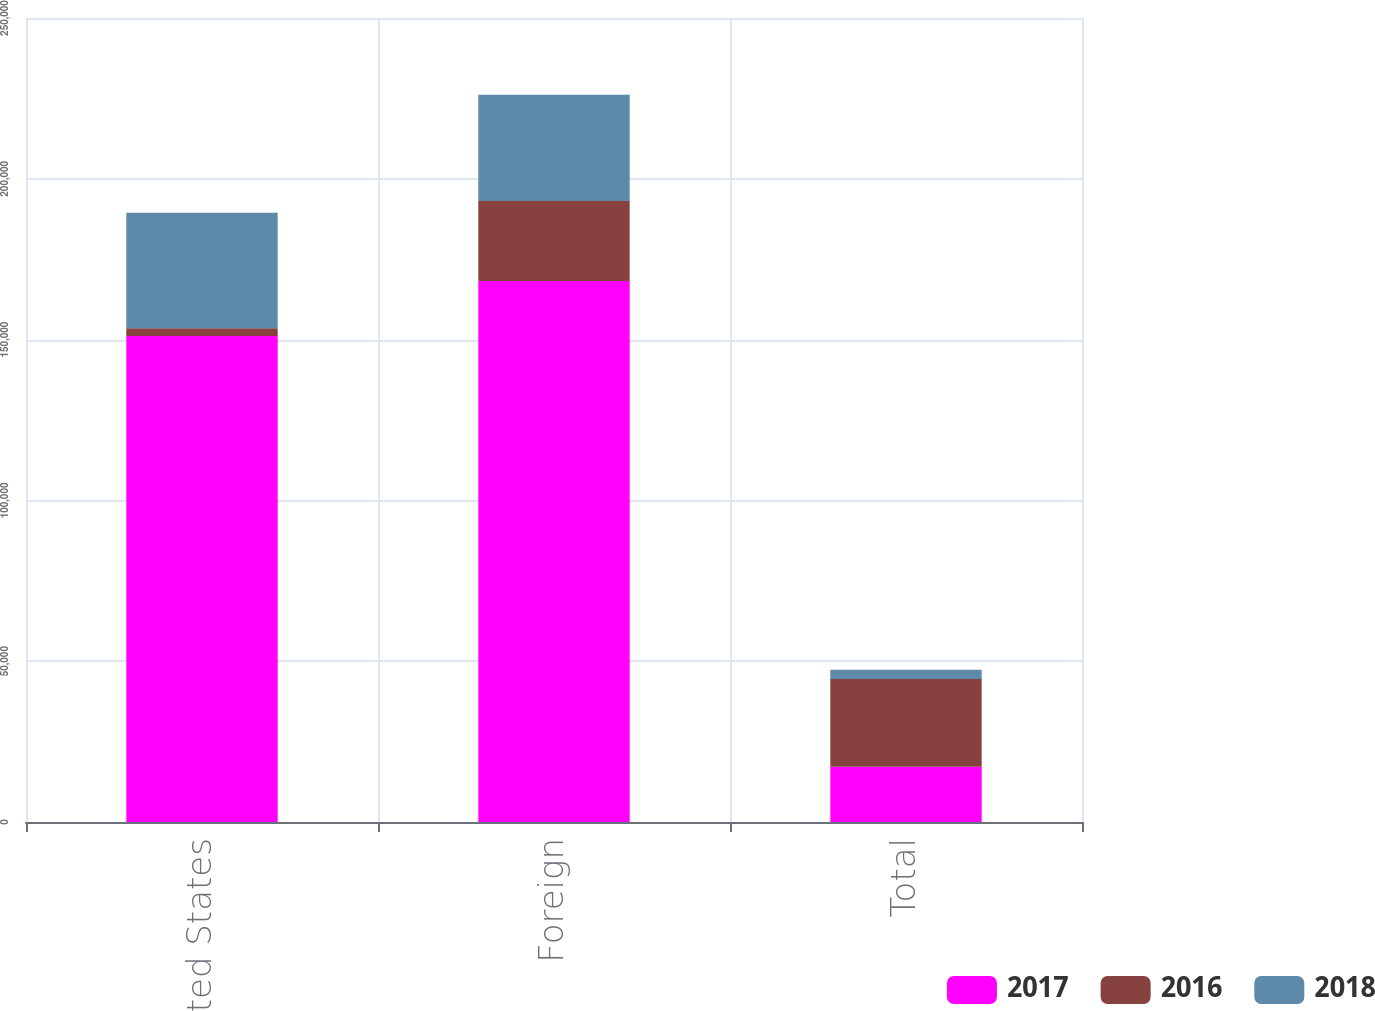Convert chart. <chart><loc_0><loc_0><loc_500><loc_500><stacked_bar_chart><ecel><fcel>United States<fcel>Foreign<fcel>Total<nl><fcel>2017<fcel>151083<fcel>168228<fcel>17145<nl><fcel>2016<fcel>2439<fcel>24866<fcel>27305<nl><fcel>2018<fcel>35923<fcel>33061<fcel>2862<nl></chart> 